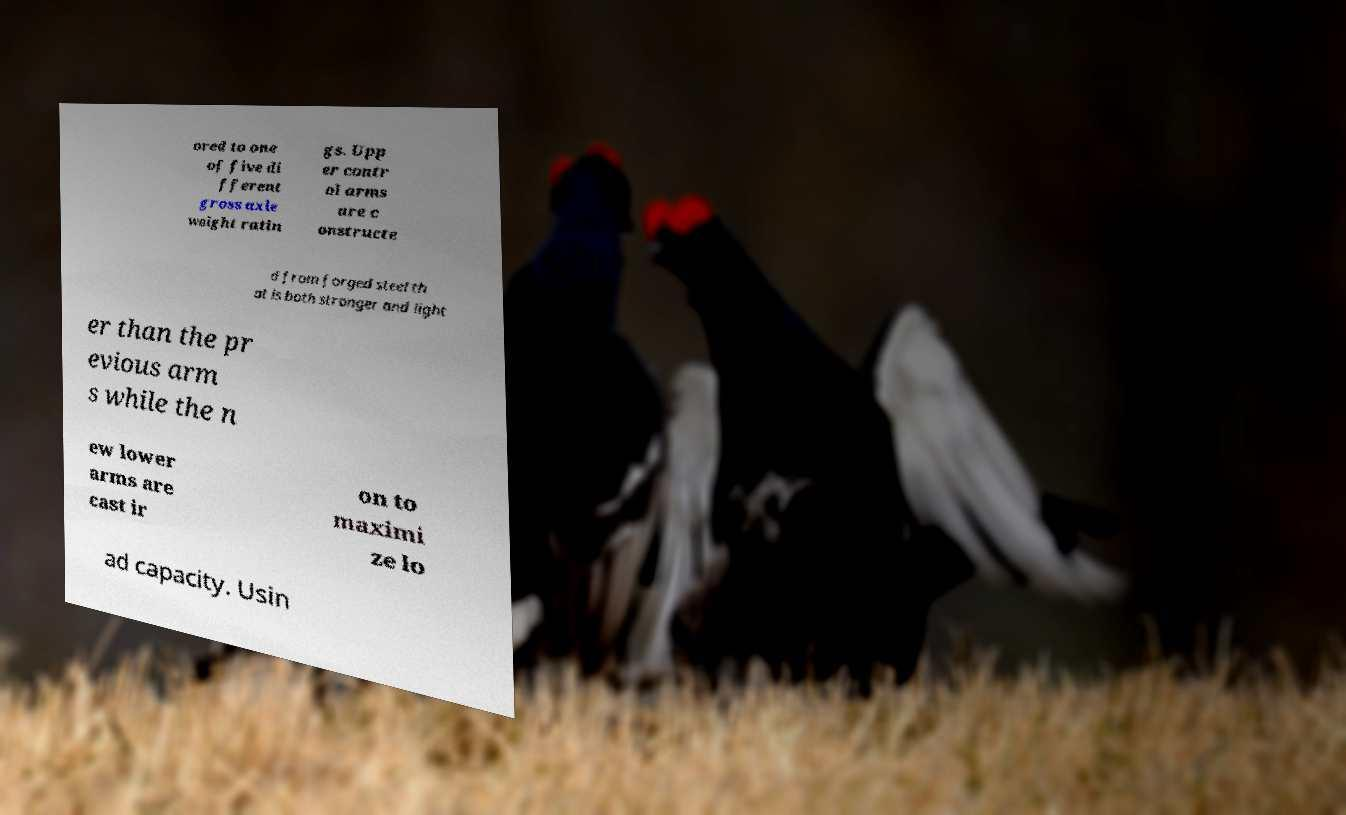Could you extract and type out the text from this image? ored to one of five di fferent gross axle weight ratin gs. Upp er contr ol arms are c onstructe d from forged steel th at is both stronger and light er than the pr evious arm s while the n ew lower arms are cast ir on to maximi ze lo ad capacity. Usin 